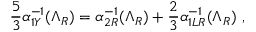Convert formula to latex. <formula><loc_0><loc_0><loc_500><loc_500>\frac { 5 } { 3 } \alpha _ { 1 Y } ^ { - 1 } ( \Lambda _ { R } ) = \alpha _ { 2 R } ^ { - 1 } ( \Lambda _ { R } ) + \frac { 2 } { 3 } \alpha _ { 1 L R } ^ { - 1 } ( \Lambda _ { R } ) \ ,</formula> 